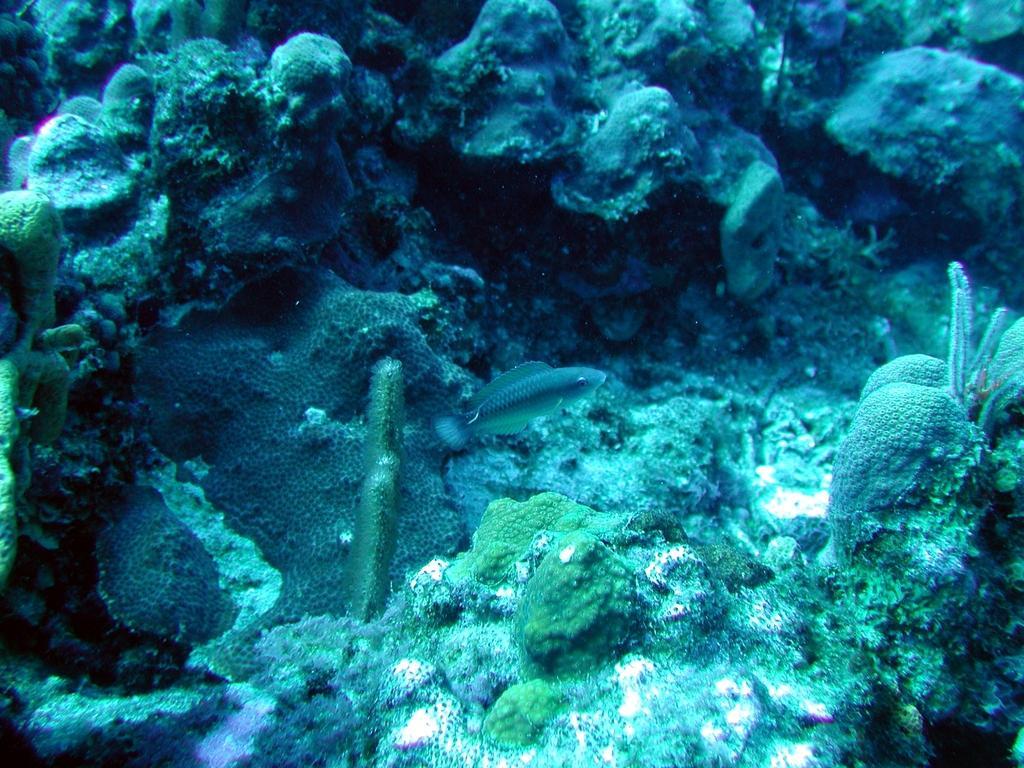How would you summarize this image in a sentence or two? In the picture we can see deep inside the sea some water rocks, plants, stones and fishes. 